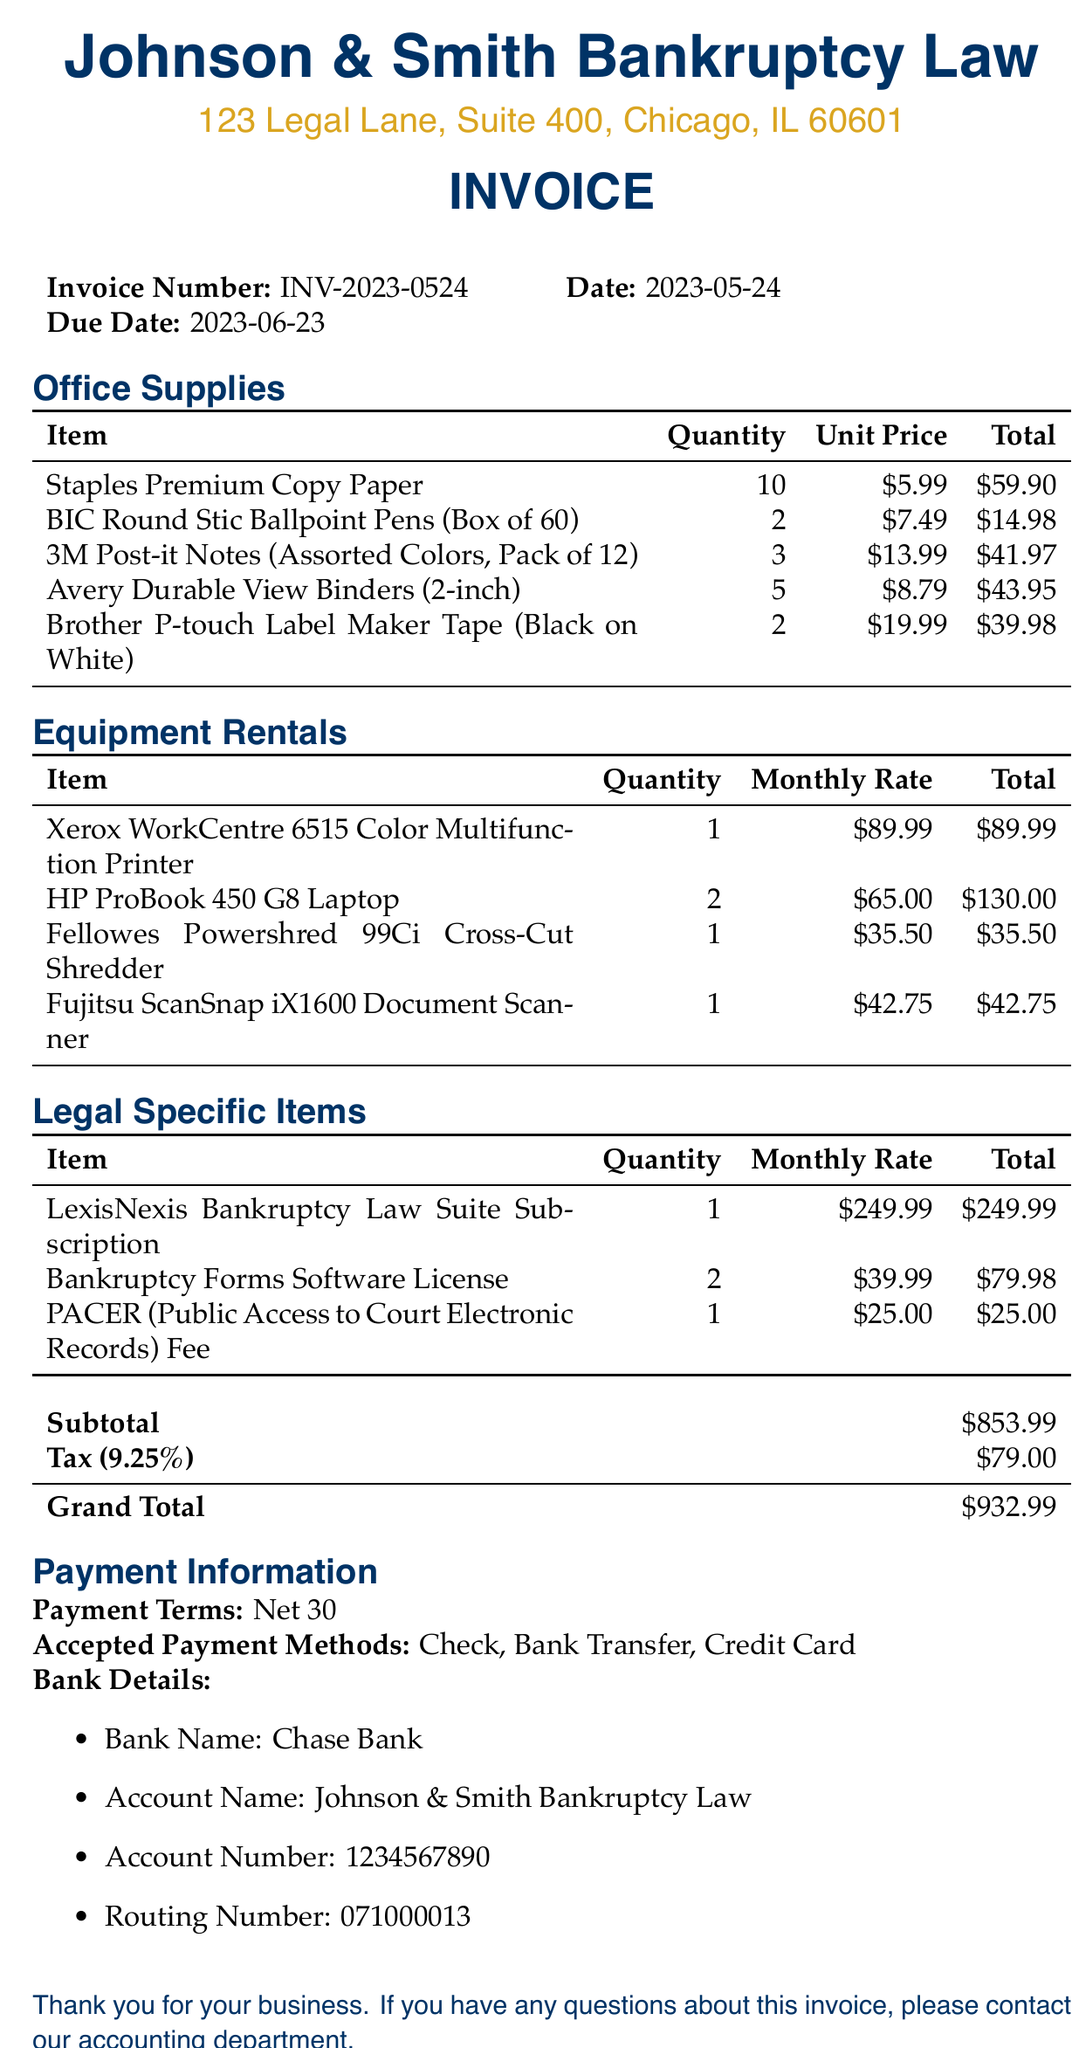what is the invoice number? The invoice number is a specific identifier for the invoice. In this case, it is provided as INV-2023-0524.
Answer: INV-2023-0524 what is the due date for this invoice? The due date indicates when the payment is expected. It is stated as 2023-06-23.
Answer: 2023-06-23 how many units of Brother P-touch Label Maker Tape were purchased? The quantity of this item reflects how many were ordered. It is listed as 2.
Answer: 2 what is the total cost for legal specific items? This total is calculated by summing the totals for all legal specific items listed in the invoice. It is shown as 354.97.
Answer: 354.97 what is the subtotal of all items before tax? The subtotal includes all items listed before calculating tax. It is explicitly provided as 853.99.
Answer: 853.99 which payment method is not accepted? The listed accepted payment methods indicate which payment types can be used to settle the invoice. A non-listed payment method can be inferred as not accepted.
Answer: Cash what is the monthly rate for the HP ProBook 450 G8 Laptop? The monthly rate specifies the cost for renting the item for a month. It is mentioned as 65.00.
Answer: 65.00 what is the total invoice amount including tax? The total amount reflects the final amount due after including tax on the subtotal. It is stated clearly as 932.99.
Answer: 932.99 how many different types of equipment rentals are listed? This refers to the distinct categories of equipment that have been rented, and there are four items listed.
Answer: 4 what is the tax rate applied to the invoice? The tax rate is a percentage used to calculate the amount of tax on the subtotal and is stated in the invoice as 9.25 percent.
Answer: 9.25 percent 